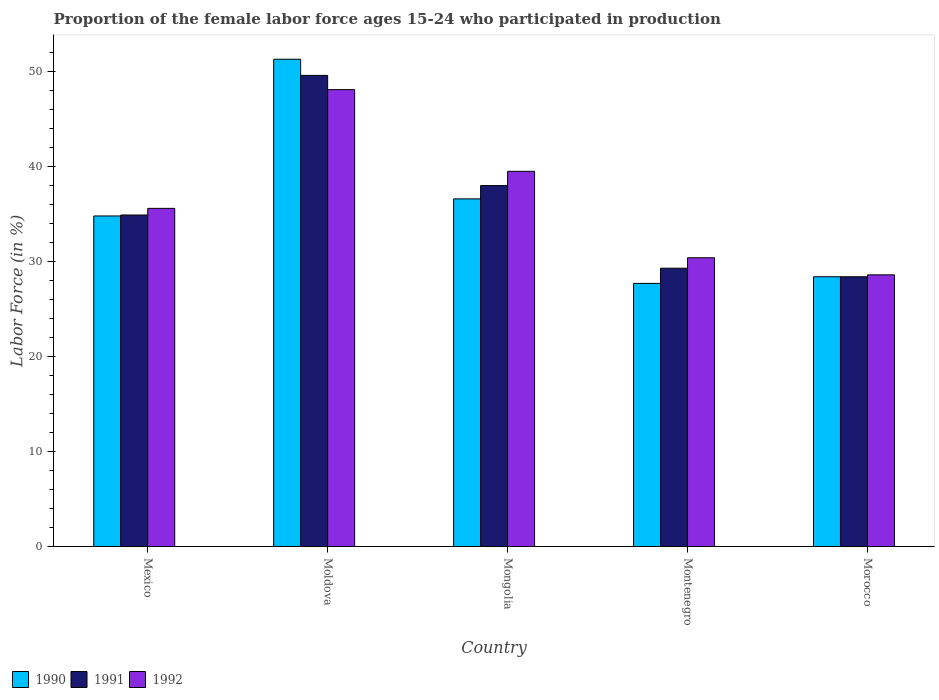How many different coloured bars are there?
Provide a short and direct response. 3. Are the number of bars per tick equal to the number of legend labels?
Offer a terse response. Yes. Are the number of bars on each tick of the X-axis equal?
Your answer should be compact. Yes. What is the label of the 2nd group of bars from the left?
Make the answer very short. Moldova. What is the proportion of the female labor force who participated in production in 1991 in Mexico?
Keep it short and to the point. 34.9. Across all countries, what is the maximum proportion of the female labor force who participated in production in 1992?
Provide a short and direct response. 48.1. Across all countries, what is the minimum proportion of the female labor force who participated in production in 1990?
Your answer should be very brief. 27.7. In which country was the proportion of the female labor force who participated in production in 1990 maximum?
Offer a very short reply. Moldova. In which country was the proportion of the female labor force who participated in production in 1991 minimum?
Provide a succinct answer. Morocco. What is the total proportion of the female labor force who participated in production in 1992 in the graph?
Give a very brief answer. 182.2. What is the difference between the proportion of the female labor force who participated in production in 1990 in Mexico and that in Mongolia?
Give a very brief answer. -1.8. What is the difference between the proportion of the female labor force who participated in production in 1992 in Morocco and the proportion of the female labor force who participated in production in 1990 in Moldova?
Keep it short and to the point. -22.7. What is the average proportion of the female labor force who participated in production in 1991 per country?
Provide a short and direct response. 36.04. What is the difference between the proportion of the female labor force who participated in production of/in 1992 and proportion of the female labor force who participated in production of/in 1991 in Mexico?
Provide a succinct answer. 0.7. In how many countries, is the proportion of the female labor force who participated in production in 1990 greater than 8 %?
Provide a short and direct response. 5. What is the ratio of the proportion of the female labor force who participated in production in 1992 in Mongolia to that in Montenegro?
Your answer should be compact. 1.3. Is the difference between the proportion of the female labor force who participated in production in 1992 in Mongolia and Morocco greater than the difference between the proportion of the female labor force who participated in production in 1991 in Mongolia and Morocco?
Ensure brevity in your answer.  Yes. What is the difference between the highest and the second highest proportion of the female labor force who participated in production in 1990?
Give a very brief answer. -16.5. What is the difference between the highest and the lowest proportion of the female labor force who participated in production in 1991?
Your response must be concise. 21.2. In how many countries, is the proportion of the female labor force who participated in production in 1991 greater than the average proportion of the female labor force who participated in production in 1991 taken over all countries?
Give a very brief answer. 2. Is the sum of the proportion of the female labor force who participated in production in 1990 in Mongolia and Montenegro greater than the maximum proportion of the female labor force who participated in production in 1992 across all countries?
Keep it short and to the point. Yes. What does the 3rd bar from the right in Morocco represents?
Keep it short and to the point. 1990. Is it the case that in every country, the sum of the proportion of the female labor force who participated in production in 1991 and proportion of the female labor force who participated in production in 1990 is greater than the proportion of the female labor force who participated in production in 1992?
Offer a very short reply. Yes. Are the values on the major ticks of Y-axis written in scientific E-notation?
Offer a terse response. No. Does the graph contain any zero values?
Your answer should be compact. No. Does the graph contain grids?
Your response must be concise. No. Where does the legend appear in the graph?
Provide a succinct answer. Bottom left. How are the legend labels stacked?
Offer a very short reply. Horizontal. What is the title of the graph?
Offer a terse response. Proportion of the female labor force ages 15-24 who participated in production. What is the label or title of the Y-axis?
Provide a short and direct response. Labor Force (in %). What is the Labor Force (in %) of 1990 in Mexico?
Keep it short and to the point. 34.8. What is the Labor Force (in %) in 1991 in Mexico?
Give a very brief answer. 34.9. What is the Labor Force (in %) in 1992 in Mexico?
Ensure brevity in your answer.  35.6. What is the Labor Force (in %) in 1990 in Moldova?
Keep it short and to the point. 51.3. What is the Labor Force (in %) in 1991 in Moldova?
Keep it short and to the point. 49.6. What is the Labor Force (in %) of 1992 in Moldova?
Make the answer very short. 48.1. What is the Labor Force (in %) in 1990 in Mongolia?
Your answer should be very brief. 36.6. What is the Labor Force (in %) in 1992 in Mongolia?
Your response must be concise. 39.5. What is the Labor Force (in %) in 1990 in Montenegro?
Your answer should be very brief. 27.7. What is the Labor Force (in %) in 1991 in Montenegro?
Offer a very short reply. 29.3. What is the Labor Force (in %) of 1992 in Montenegro?
Make the answer very short. 30.4. What is the Labor Force (in %) in 1990 in Morocco?
Provide a short and direct response. 28.4. What is the Labor Force (in %) of 1991 in Morocco?
Ensure brevity in your answer.  28.4. What is the Labor Force (in %) in 1992 in Morocco?
Your response must be concise. 28.6. Across all countries, what is the maximum Labor Force (in %) of 1990?
Provide a succinct answer. 51.3. Across all countries, what is the maximum Labor Force (in %) of 1991?
Offer a very short reply. 49.6. Across all countries, what is the maximum Labor Force (in %) in 1992?
Your answer should be very brief. 48.1. Across all countries, what is the minimum Labor Force (in %) of 1990?
Give a very brief answer. 27.7. Across all countries, what is the minimum Labor Force (in %) in 1991?
Offer a very short reply. 28.4. Across all countries, what is the minimum Labor Force (in %) in 1992?
Offer a very short reply. 28.6. What is the total Labor Force (in %) of 1990 in the graph?
Provide a succinct answer. 178.8. What is the total Labor Force (in %) in 1991 in the graph?
Give a very brief answer. 180.2. What is the total Labor Force (in %) of 1992 in the graph?
Offer a very short reply. 182.2. What is the difference between the Labor Force (in %) of 1990 in Mexico and that in Moldova?
Offer a terse response. -16.5. What is the difference between the Labor Force (in %) in 1991 in Mexico and that in Moldova?
Ensure brevity in your answer.  -14.7. What is the difference between the Labor Force (in %) in 1990 in Mexico and that in Mongolia?
Offer a very short reply. -1.8. What is the difference between the Labor Force (in %) of 1991 in Mexico and that in Montenegro?
Offer a very short reply. 5.6. What is the difference between the Labor Force (in %) in 1992 in Mexico and that in Montenegro?
Ensure brevity in your answer.  5.2. What is the difference between the Labor Force (in %) of 1990 in Moldova and that in Mongolia?
Keep it short and to the point. 14.7. What is the difference between the Labor Force (in %) of 1991 in Moldova and that in Mongolia?
Offer a terse response. 11.6. What is the difference between the Labor Force (in %) in 1990 in Moldova and that in Montenegro?
Provide a short and direct response. 23.6. What is the difference between the Labor Force (in %) of 1991 in Moldova and that in Montenegro?
Your response must be concise. 20.3. What is the difference between the Labor Force (in %) in 1992 in Moldova and that in Montenegro?
Your response must be concise. 17.7. What is the difference between the Labor Force (in %) of 1990 in Moldova and that in Morocco?
Give a very brief answer. 22.9. What is the difference between the Labor Force (in %) of 1991 in Moldova and that in Morocco?
Give a very brief answer. 21.2. What is the difference between the Labor Force (in %) of 1992 in Moldova and that in Morocco?
Your answer should be compact. 19.5. What is the difference between the Labor Force (in %) in 1992 in Mongolia and that in Montenegro?
Ensure brevity in your answer.  9.1. What is the difference between the Labor Force (in %) of 1991 in Mongolia and that in Morocco?
Ensure brevity in your answer.  9.6. What is the difference between the Labor Force (in %) of 1992 in Mongolia and that in Morocco?
Your answer should be compact. 10.9. What is the difference between the Labor Force (in %) in 1990 in Mexico and the Labor Force (in %) in 1991 in Moldova?
Keep it short and to the point. -14.8. What is the difference between the Labor Force (in %) in 1990 in Mexico and the Labor Force (in %) in 1992 in Moldova?
Offer a terse response. -13.3. What is the difference between the Labor Force (in %) of 1991 in Mexico and the Labor Force (in %) of 1992 in Moldova?
Your answer should be compact. -13.2. What is the difference between the Labor Force (in %) in 1990 in Mexico and the Labor Force (in %) in 1991 in Mongolia?
Ensure brevity in your answer.  -3.2. What is the difference between the Labor Force (in %) in 1991 in Mexico and the Labor Force (in %) in 1992 in Mongolia?
Give a very brief answer. -4.6. What is the difference between the Labor Force (in %) in 1990 in Mexico and the Labor Force (in %) in 1991 in Montenegro?
Provide a short and direct response. 5.5. What is the difference between the Labor Force (in %) of 1990 in Mexico and the Labor Force (in %) of 1992 in Montenegro?
Ensure brevity in your answer.  4.4. What is the difference between the Labor Force (in %) in 1990 in Mexico and the Labor Force (in %) in 1992 in Morocco?
Provide a succinct answer. 6.2. What is the difference between the Labor Force (in %) in 1991 in Mexico and the Labor Force (in %) in 1992 in Morocco?
Your response must be concise. 6.3. What is the difference between the Labor Force (in %) of 1990 in Moldova and the Labor Force (in %) of 1991 in Mongolia?
Your response must be concise. 13.3. What is the difference between the Labor Force (in %) in 1990 in Moldova and the Labor Force (in %) in 1992 in Montenegro?
Offer a very short reply. 20.9. What is the difference between the Labor Force (in %) in 1990 in Moldova and the Labor Force (in %) in 1991 in Morocco?
Ensure brevity in your answer.  22.9. What is the difference between the Labor Force (in %) in 1990 in Moldova and the Labor Force (in %) in 1992 in Morocco?
Give a very brief answer. 22.7. What is the difference between the Labor Force (in %) in 1991 in Montenegro and the Labor Force (in %) in 1992 in Morocco?
Ensure brevity in your answer.  0.7. What is the average Labor Force (in %) in 1990 per country?
Give a very brief answer. 35.76. What is the average Labor Force (in %) in 1991 per country?
Keep it short and to the point. 36.04. What is the average Labor Force (in %) in 1992 per country?
Your answer should be very brief. 36.44. What is the difference between the Labor Force (in %) in 1990 and Labor Force (in %) in 1991 in Mexico?
Ensure brevity in your answer.  -0.1. What is the difference between the Labor Force (in %) in 1990 and Labor Force (in %) in 1992 in Mexico?
Keep it short and to the point. -0.8. What is the difference between the Labor Force (in %) of 1990 and Labor Force (in %) of 1991 in Moldova?
Give a very brief answer. 1.7. What is the difference between the Labor Force (in %) in 1990 and Labor Force (in %) in 1992 in Moldova?
Your answer should be very brief. 3.2. What is the difference between the Labor Force (in %) of 1990 and Labor Force (in %) of 1991 in Mongolia?
Your answer should be compact. -1.4. What is the difference between the Labor Force (in %) in 1991 and Labor Force (in %) in 1992 in Mongolia?
Your response must be concise. -1.5. What is the difference between the Labor Force (in %) in 1990 and Labor Force (in %) in 1991 in Montenegro?
Give a very brief answer. -1.6. What is the difference between the Labor Force (in %) of 1991 and Labor Force (in %) of 1992 in Montenegro?
Your answer should be very brief. -1.1. What is the difference between the Labor Force (in %) in 1990 and Labor Force (in %) in 1992 in Morocco?
Offer a terse response. -0.2. What is the difference between the Labor Force (in %) of 1991 and Labor Force (in %) of 1992 in Morocco?
Provide a short and direct response. -0.2. What is the ratio of the Labor Force (in %) in 1990 in Mexico to that in Moldova?
Offer a very short reply. 0.68. What is the ratio of the Labor Force (in %) in 1991 in Mexico to that in Moldova?
Provide a succinct answer. 0.7. What is the ratio of the Labor Force (in %) in 1992 in Mexico to that in Moldova?
Offer a very short reply. 0.74. What is the ratio of the Labor Force (in %) in 1990 in Mexico to that in Mongolia?
Keep it short and to the point. 0.95. What is the ratio of the Labor Force (in %) in 1991 in Mexico to that in Mongolia?
Your answer should be compact. 0.92. What is the ratio of the Labor Force (in %) in 1992 in Mexico to that in Mongolia?
Ensure brevity in your answer.  0.9. What is the ratio of the Labor Force (in %) of 1990 in Mexico to that in Montenegro?
Your answer should be compact. 1.26. What is the ratio of the Labor Force (in %) in 1991 in Mexico to that in Montenegro?
Your answer should be very brief. 1.19. What is the ratio of the Labor Force (in %) of 1992 in Mexico to that in Montenegro?
Keep it short and to the point. 1.17. What is the ratio of the Labor Force (in %) in 1990 in Mexico to that in Morocco?
Your response must be concise. 1.23. What is the ratio of the Labor Force (in %) in 1991 in Mexico to that in Morocco?
Provide a succinct answer. 1.23. What is the ratio of the Labor Force (in %) of 1992 in Mexico to that in Morocco?
Offer a terse response. 1.24. What is the ratio of the Labor Force (in %) of 1990 in Moldova to that in Mongolia?
Your answer should be compact. 1.4. What is the ratio of the Labor Force (in %) in 1991 in Moldova to that in Mongolia?
Offer a very short reply. 1.31. What is the ratio of the Labor Force (in %) in 1992 in Moldova to that in Mongolia?
Offer a terse response. 1.22. What is the ratio of the Labor Force (in %) of 1990 in Moldova to that in Montenegro?
Offer a very short reply. 1.85. What is the ratio of the Labor Force (in %) of 1991 in Moldova to that in Montenegro?
Offer a terse response. 1.69. What is the ratio of the Labor Force (in %) in 1992 in Moldova to that in Montenegro?
Keep it short and to the point. 1.58. What is the ratio of the Labor Force (in %) in 1990 in Moldova to that in Morocco?
Keep it short and to the point. 1.81. What is the ratio of the Labor Force (in %) of 1991 in Moldova to that in Morocco?
Offer a very short reply. 1.75. What is the ratio of the Labor Force (in %) of 1992 in Moldova to that in Morocco?
Provide a short and direct response. 1.68. What is the ratio of the Labor Force (in %) in 1990 in Mongolia to that in Montenegro?
Your answer should be compact. 1.32. What is the ratio of the Labor Force (in %) of 1991 in Mongolia to that in Montenegro?
Offer a terse response. 1.3. What is the ratio of the Labor Force (in %) of 1992 in Mongolia to that in Montenegro?
Provide a short and direct response. 1.3. What is the ratio of the Labor Force (in %) of 1990 in Mongolia to that in Morocco?
Your response must be concise. 1.29. What is the ratio of the Labor Force (in %) in 1991 in Mongolia to that in Morocco?
Offer a very short reply. 1.34. What is the ratio of the Labor Force (in %) in 1992 in Mongolia to that in Morocco?
Give a very brief answer. 1.38. What is the ratio of the Labor Force (in %) of 1990 in Montenegro to that in Morocco?
Give a very brief answer. 0.98. What is the ratio of the Labor Force (in %) in 1991 in Montenegro to that in Morocco?
Provide a succinct answer. 1.03. What is the ratio of the Labor Force (in %) in 1992 in Montenegro to that in Morocco?
Give a very brief answer. 1.06. What is the difference between the highest and the second highest Labor Force (in %) of 1992?
Offer a terse response. 8.6. What is the difference between the highest and the lowest Labor Force (in %) of 1990?
Offer a very short reply. 23.6. What is the difference between the highest and the lowest Labor Force (in %) in 1991?
Your response must be concise. 21.2. What is the difference between the highest and the lowest Labor Force (in %) of 1992?
Ensure brevity in your answer.  19.5. 